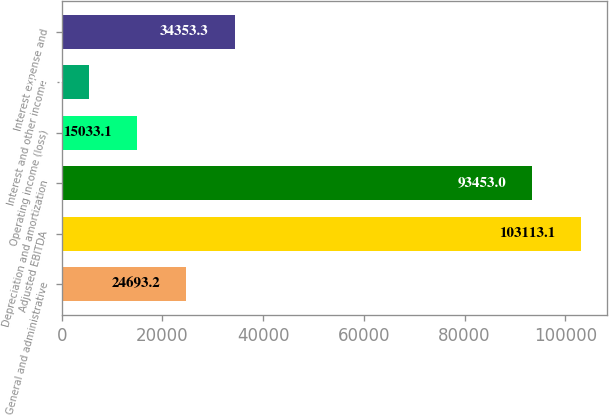Convert chart. <chart><loc_0><loc_0><loc_500><loc_500><bar_chart><fcel>General and administrative<fcel>Adjusted EBITDA<fcel>Depreciation and amortization<fcel>Operating income (loss)<fcel>Interest and other income<fcel>Interest expense and<nl><fcel>24693.2<fcel>103113<fcel>93453<fcel>15033.1<fcel>5373<fcel>34353.3<nl></chart> 